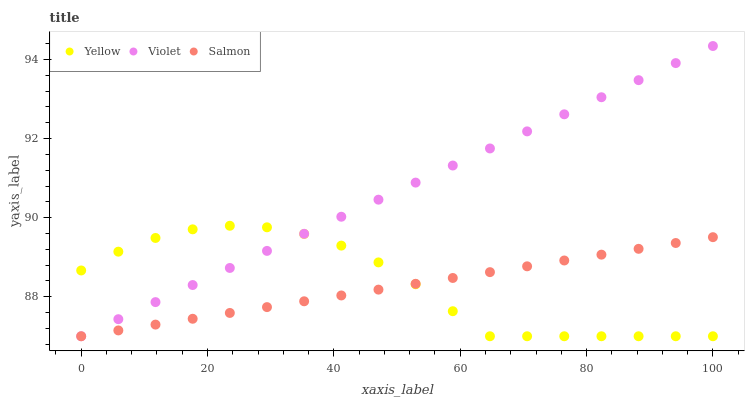Does Salmon have the minimum area under the curve?
Answer yes or no. Yes. Does Violet have the maximum area under the curve?
Answer yes or no. Yes. Does Yellow have the minimum area under the curve?
Answer yes or no. No. Does Yellow have the maximum area under the curve?
Answer yes or no. No. Is Violet the smoothest?
Answer yes or no. Yes. Is Yellow the roughest?
Answer yes or no. Yes. Is Yellow the smoothest?
Answer yes or no. No. Is Violet the roughest?
Answer yes or no. No. Does Salmon have the lowest value?
Answer yes or no. Yes. Does Violet have the highest value?
Answer yes or no. Yes. Does Yellow have the highest value?
Answer yes or no. No. Does Salmon intersect Yellow?
Answer yes or no. Yes. Is Salmon less than Yellow?
Answer yes or no. No. Is Salmon greater than Yellow?
Answer yes or no. No. 